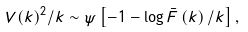Convert formula to latex. <formula><loc_0><loc_0><loc_500><loc_500>V ( k ) ^ { 2 } / k \sim \psi \left [ - 1 - \log \bar { F } \left ( k \right ) / k \right ] ,</formula> 